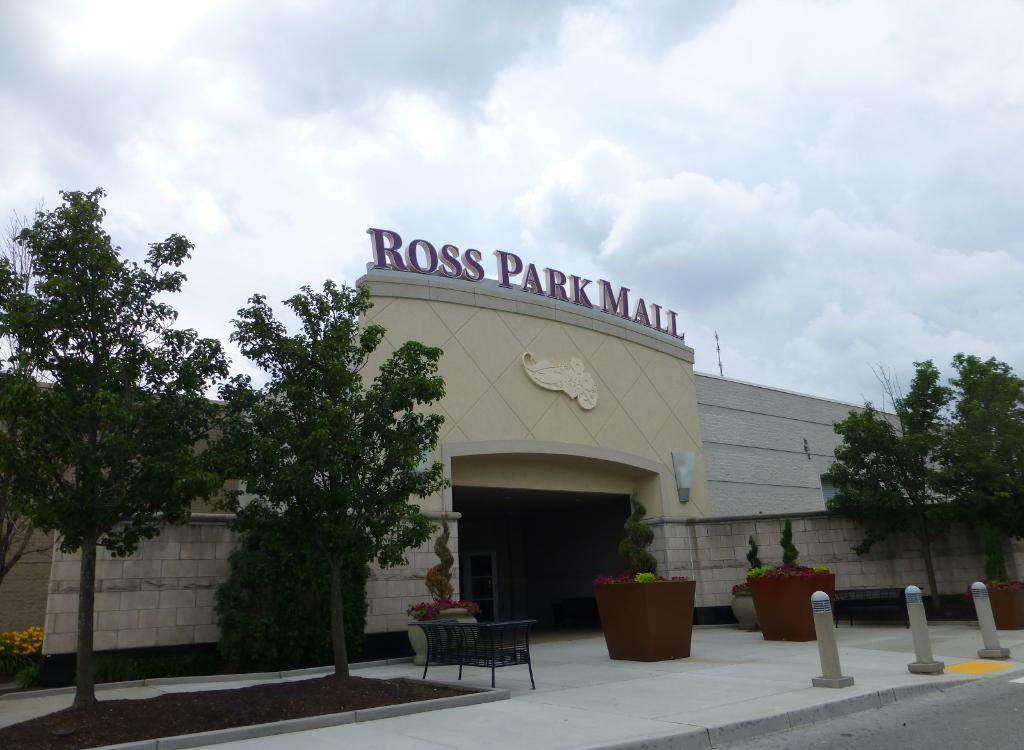What type of structure is in the image? There is a building in the image. What other natural elements can be seen in the image? There are trees in the image. What type of seating is available in the image? There is a bench in the image. What decorative items are present in the image? Flower pots are present in the image. What type of vertical structure is in the image? There is a pole in the image. What type of pathway is visible in the image? A pathway is visible in the image. What is the condition of the sky in the image? The sky is visible in the image, and it appears cloudy. How many pets are visible in the image? There are no pets present in the image. What stage of development is the yak in the image? There is no yak present in the image. 